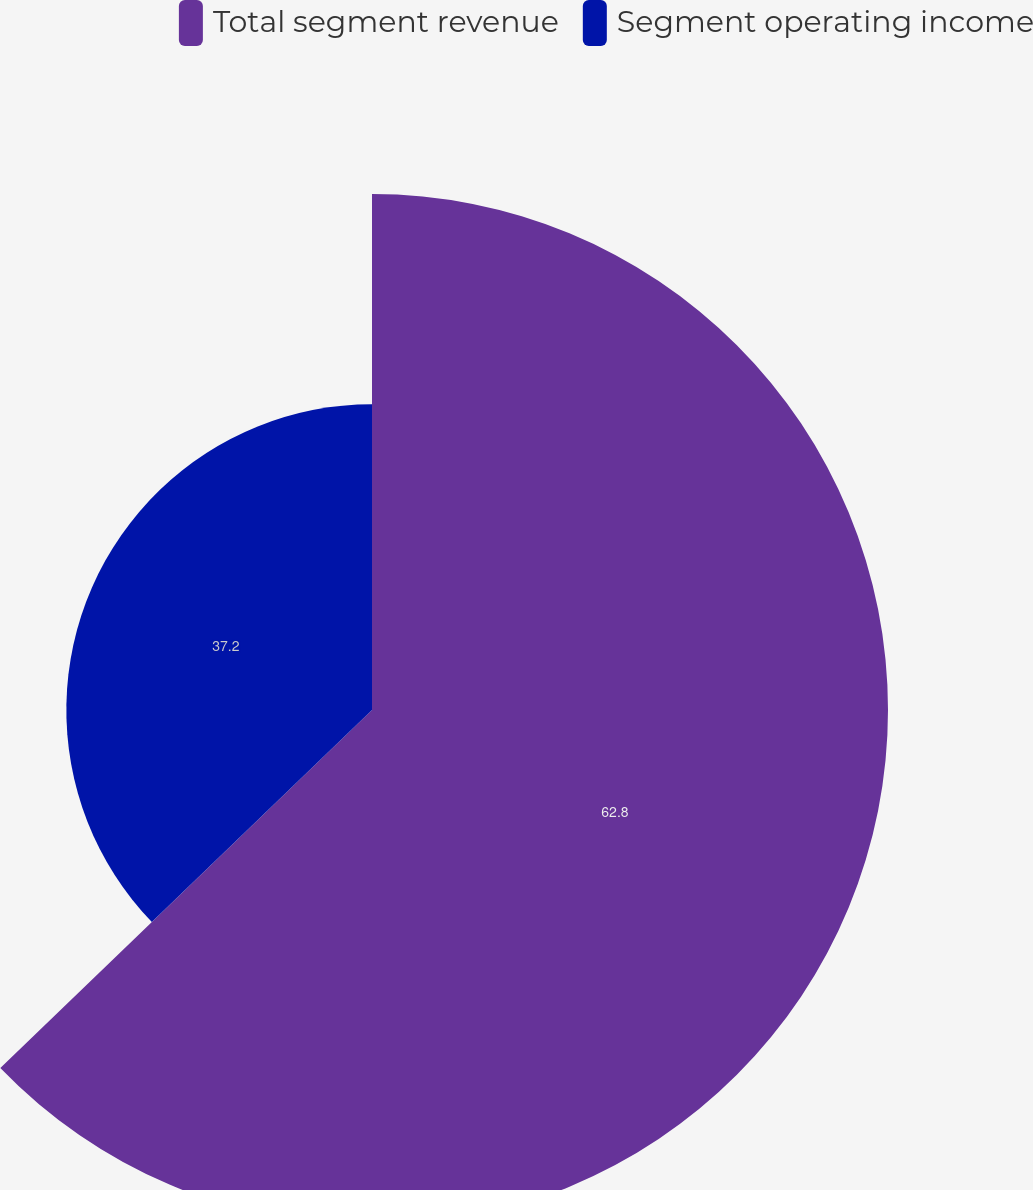<chart> <loc_0><loc_0><loc_500><loc_500><pie_chart><fcel>Total segment revenue<fcel>Segment operating income<nl><fcel>62.8%<fcel>37.2%<nl></chart> 